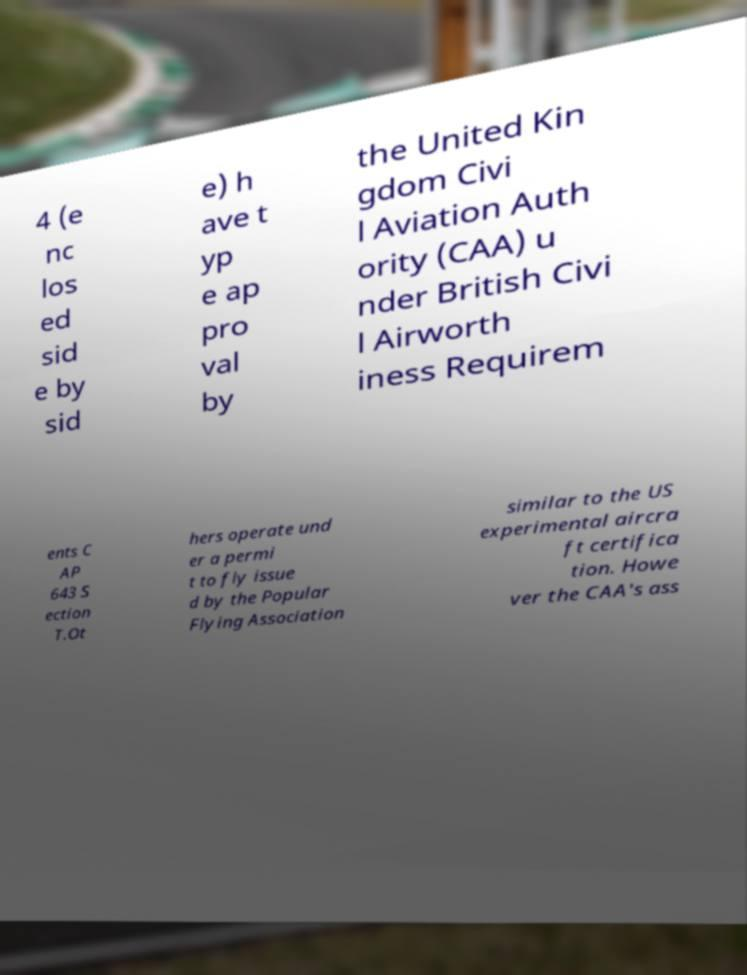Can you read and provide the text displayed in the image?This photo seems to have some interesting text. Can you extract and type it out for me? 4 (e nc los ed sid e by sid e) h ave t yp e ap pro val by the United Kin gdom Civi l Aviation Auth ority (CAA) u nder British Civi l Airworth iness Requirem ents C AP 643 S ection T.Ot hers operate und er a permi t to fly issue d by the Popular Flying Association similar to the US experimental aircra ft certifica tion. Howe ver the CAA's ass 